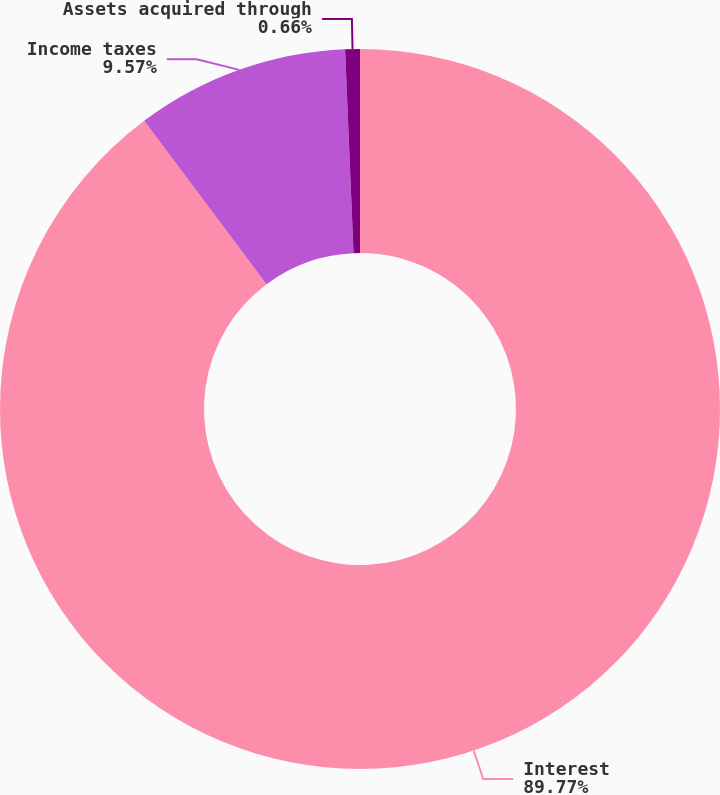<chart> <loc_0><loc_0><loc_500><loc_500><pie_chart><fcel>Interest<fcel>Income taxes<fcel>Assets acquired through<nl><fcel>89.77%<fcel>9.57%<fcel>0.66%<nl></chart> 